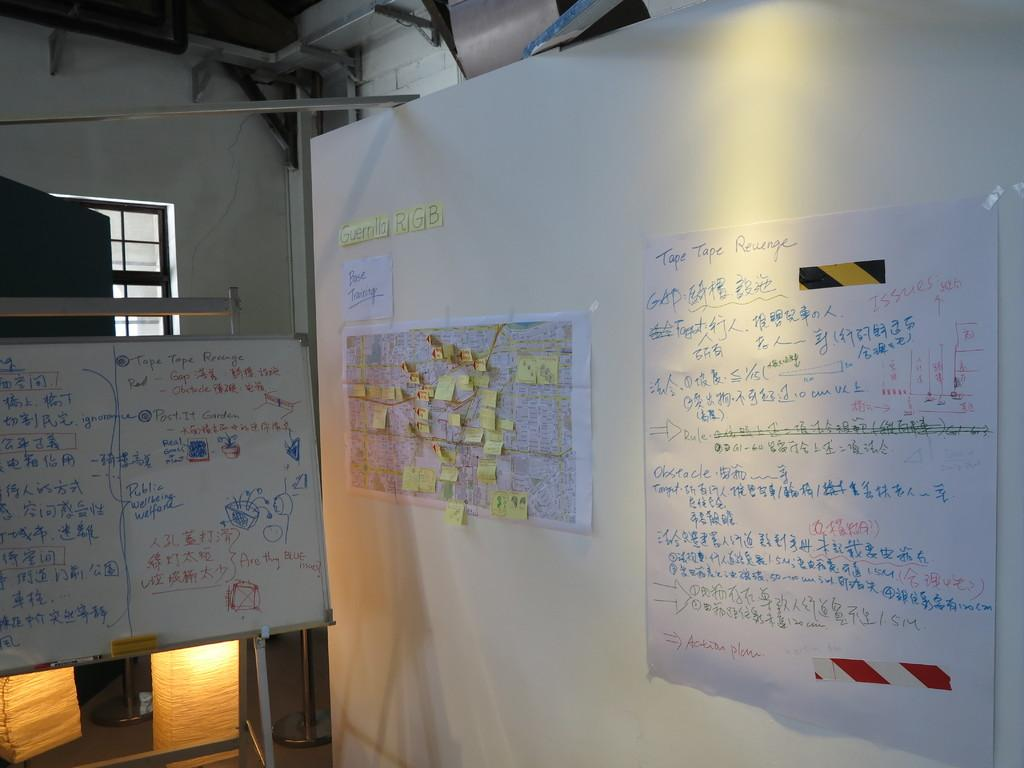<image>
Give a short and clear explanation of the subsequent image. The bottom of the right page of notes refers to an Action plan. 